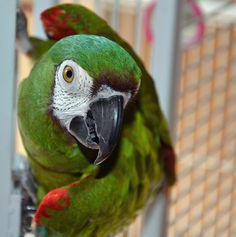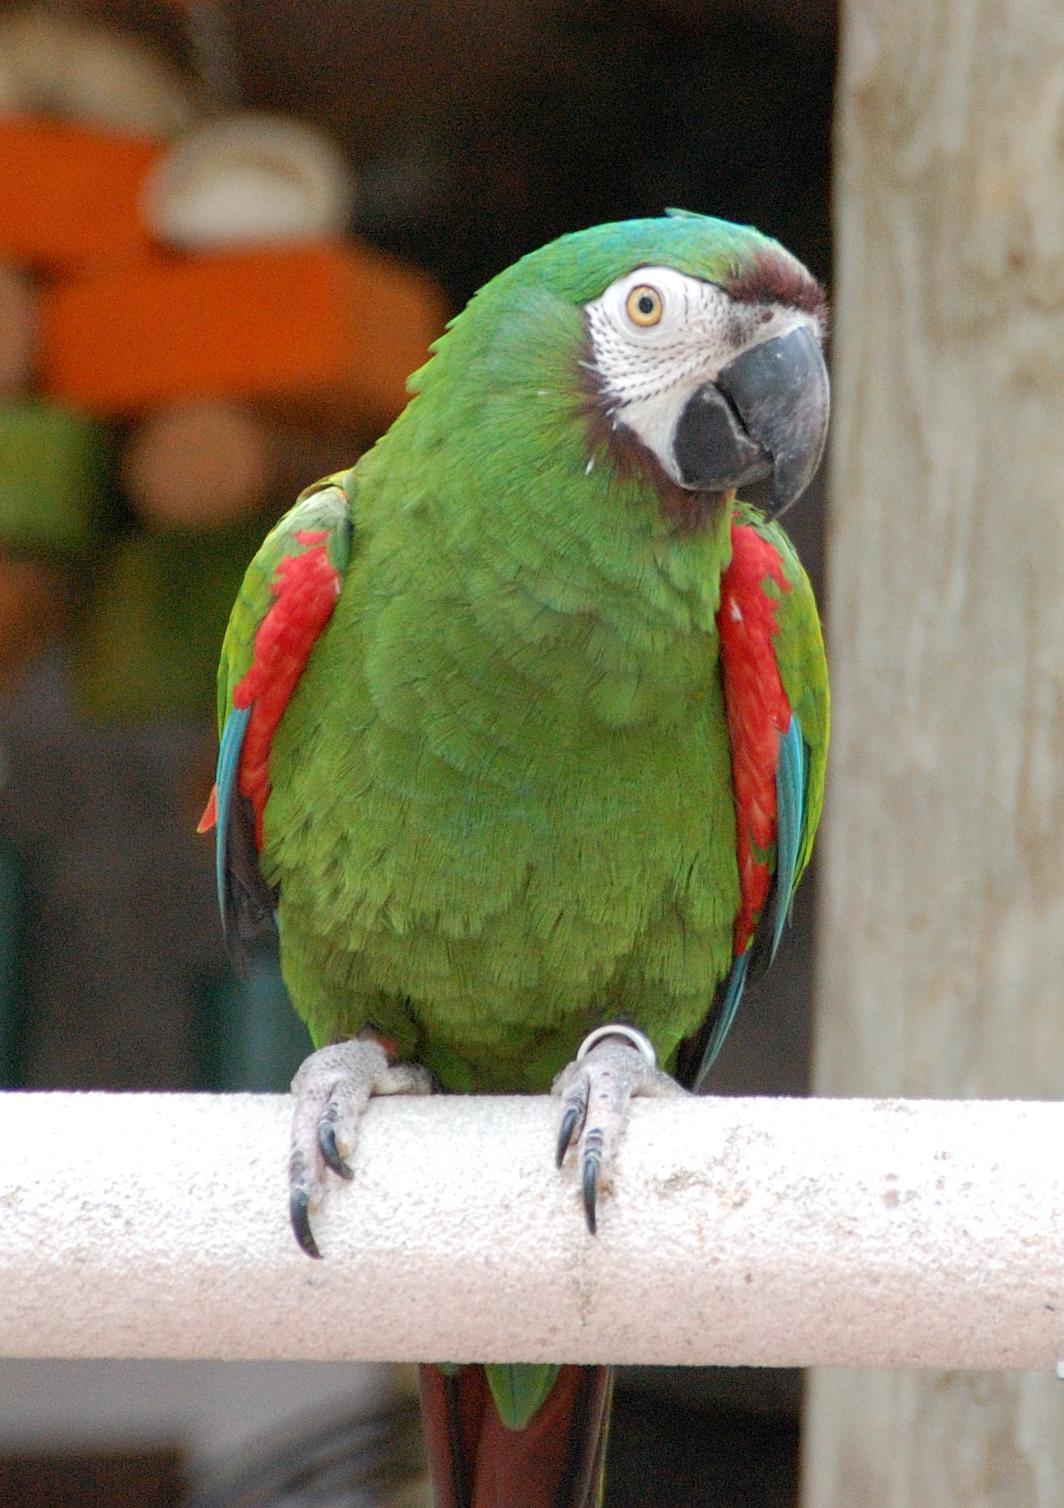The first image is the image on the left, the second image is the image on the right. Assess this claim about the two images: "In each image, the parrot faces rightward.". Correct or not? Answer yes or no. Yes. The first image is the image on the left, the second image is the image on the right. For the images displayed, is the sentence "The bird in the right image is using a tree branch for its perch." factually correct? Answer yes or no. No. 